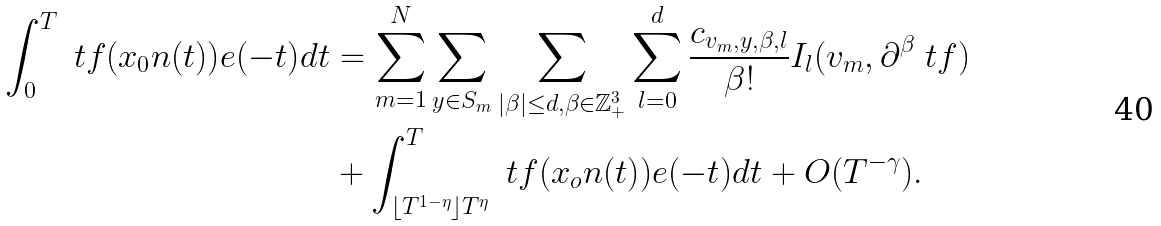<formula> <loc_0><loc_0><loc_500><loc_500>\int _ { 0 } ^ { T } \ t f ( x _ { 0 } n ( t ) ) e ( - t ) d t & = \sum _ { m = 1 } ^ { N } \sum _ { y \in S _ { m } } \sum _ { | \beta | \leq d , \beta \in \mathbb { Z } _ { + } ^ { 3 } } \sum _ { l = 0 } ^ { d } \frac { c _ { v _ { m } , y , \beta , l } } { \beta ! } I _ { l } ( v _ { m } , \partial ^ { \beta } \ t f ) \\ & + \int _ { \lfloor T ^ { 1 - \eta } \rfloor T ^ { \eta } } ^ { T } \ t f ( x _ { o } n ( t ) ) e ( - t ) d t + O ( T ^ { - \gamma } ) .</formula> 